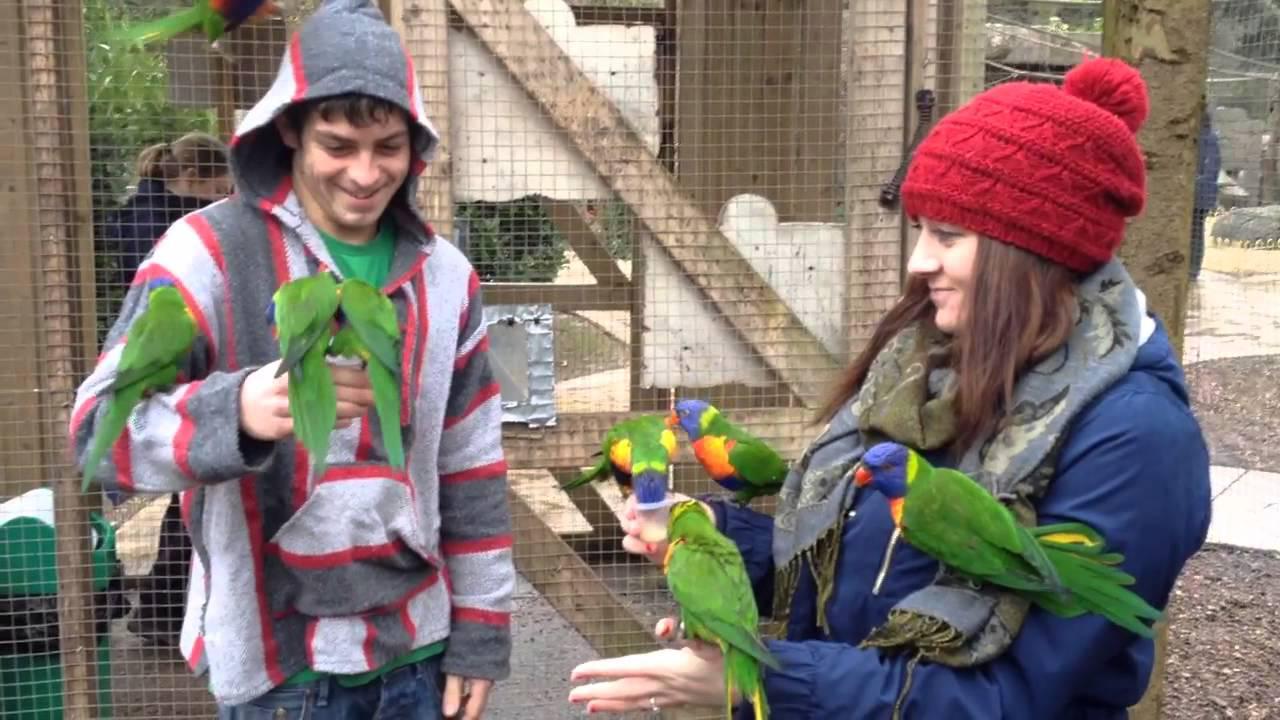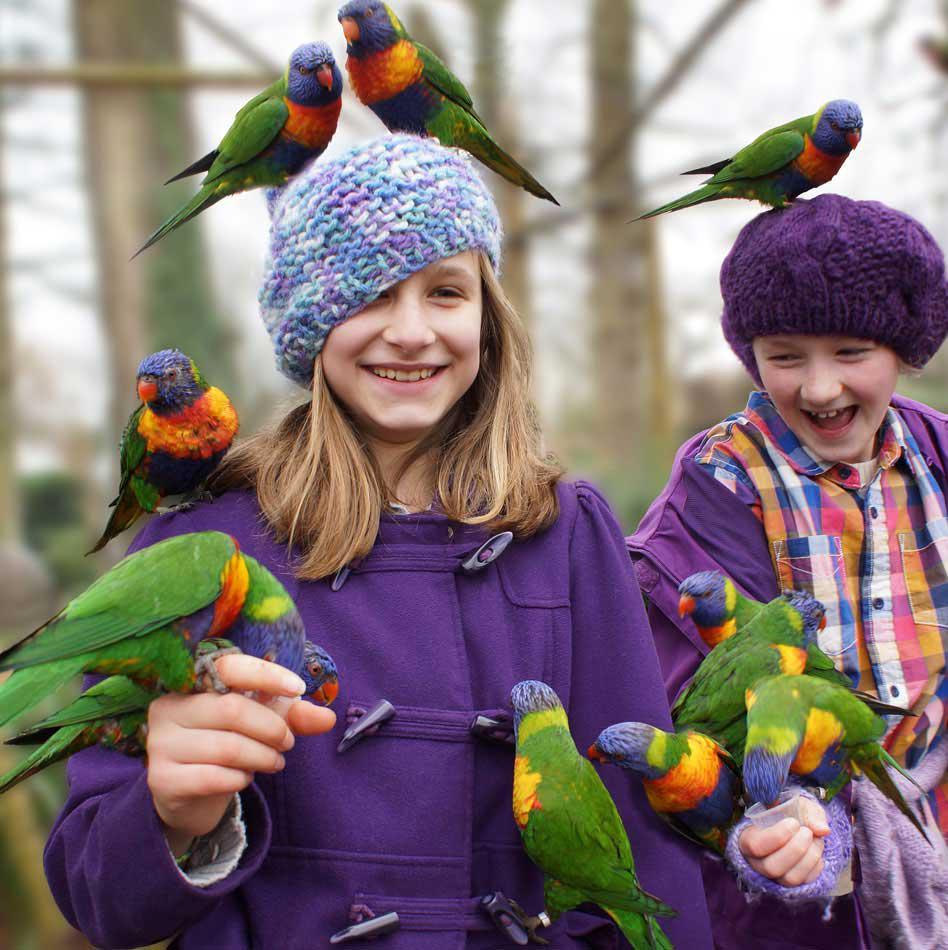The first image is the image on the left, the second image is the image on the right. Considering the images on both sides, is "One smiling woman who is not wearing a hat has exactly one green bird perched on her head." valid? Answer yes or no. No. The first image is the image on the left, the second image is the image on the right. Analyze the images presented: Is the assertion "An image shows a person with more than one parrot atop her head." valid? Answer yes or no. Yes. 